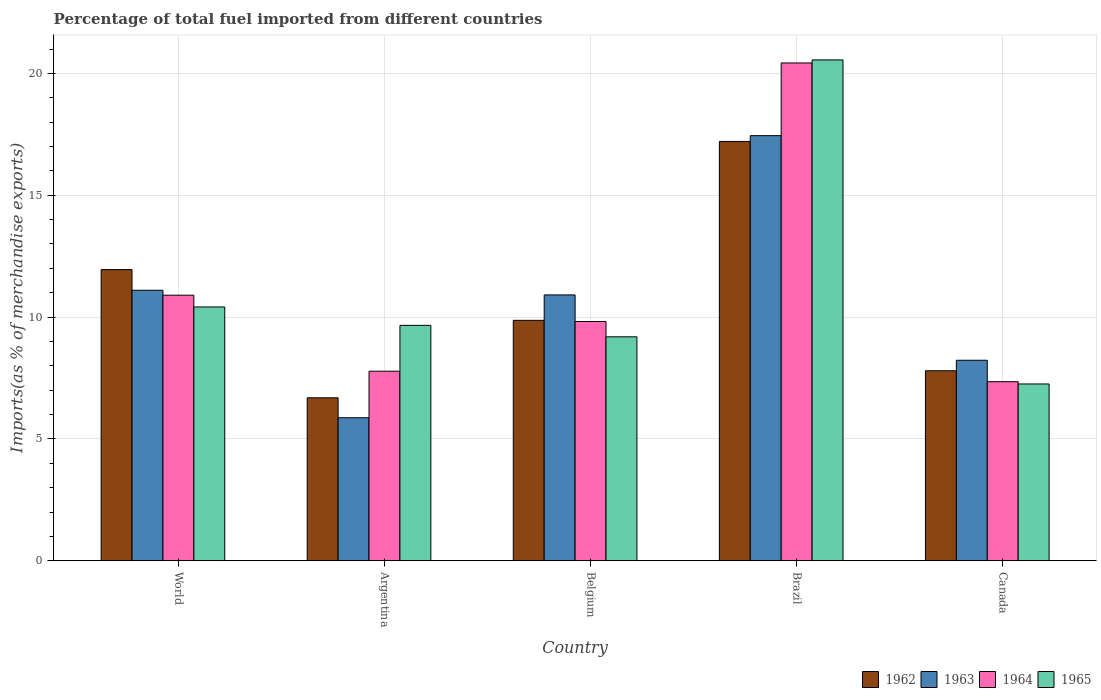How many different coloured bars are there?
Make the answer very short. 4. How many bars are there on the 5th tick from the right?
Make the answer very short. 4. In how many cases, is the number of bars for a given country not equal to the number of legend labels?
Your answer should be compact. 0. What is the percentage of imports to different countries in 1964 in World?
Give a very brief answer. 10.9. Across all countries, what is the maximum percentage of imports to different countries in 1963?
Provide a short and direct response. 17.45. Across all countries, what is the minimum percentage of imports to different countries in 1965?
Offer a terse response. 7.26. In which country was the percentage of imports to different countries in 1963 maximum?
Offer a terse response. Brazil. What is the total percentage of imports to different countries in 1964 in the graph?
Offer a terse response. 56.28. What is the difference between the percentage of imports to different countries in 1964 in Canada and that in World?
Provide a short and direct response. -3.55. What is the difference between the percentage of imports to different countries in 1965 in Argentina and the percentage of imports to different countries in 1964 in Belgium?
Your answer should be compact. -0.16. What is the average percentage of imports to different countries in 1963 per country?
Make the answer very short. 10.71. What is the difference between the percentage of imports to different countries of/in 1963 and percentage of imports to different countries of/in 1964 in Belgium?
Your answer should be very brief. 1.09. What is the ratio of the percentage of imports to different countries in 1965 in Argentina to that in Brazil?
Your answer should be very brief. 0.47. Is the percentage of imports to different countries in 1965 in Brazil less than that in Canada?
Your response must be concise. No. Is the difference between the percentage of imports to different countries in 1963 in Belgium and World greater than the difference between the percentage of imports to different countries in 1964 in Belgium and World?
Your response must be concise. Yes. What is the difference between the highest and the second highest percentage of imports to different countries in 1965?
Your answer should be very brief. -0.75. What is the difference between the highest and the lowest percentage of imports to different countries in 1963?
Your response must be concise. 11.58. In how many countries, is the percentage of imports to different countries in 1963 greater than the average percentage of imports to different countries in 1963 taken over all countries?
Ensure brevity in your answer.  3. Is the sum of the percentage of imports to different countries in 1962 in Belgium and Canada greater than the maximum percentage of imports to different countries in 1963 across all countries?
Your answer should be very brief. Yes. What does the 4th bar from the left in World represents?
Offer a very short reply. 1965. What does the 4th bar from the right in Brazil represents?
Your answer should be very brief. 1962. Is it the case that in every country, the sum of the percentage of imports to different countries in 1962 and percentage of imports to different countries in 1964 is greater than the percentage of imports to different countries in 1963?
Your answer should be very brief. Yes. How many bars are there?
Your answer should be very brief. 20. How many countries are there in the graph?
Your response must be concise. 5. Are the values on the major ticks of Y-axis written in scientific E-notation?
Make the answer very short. No. Does the graph contain any zero values?
Give a very brief answer. No. Does the graph contain grids?
Keep it short and to the point. Yes. Where does the legend appear in the graph?
Keep it short and to the point. Bottom right. How many legend labels are there?
Provide a succinct answer. 4. What is the title of the graph?
Keep it short and to the point. Percentage of total fuel imported from different countries. Does "2009" appear as one of the legend labels in the graph?
Provide a succinct answer. No. What is the label or title of the Y-axis?
Give a very brief answer. Imports(as % of merchandise exports). What is the Imports(as % of merchandise exports) of 1962 in World?
Provide a short and direct response. 11.95. What is the Imports(as % of merchandise exports) in 1963 in World?
Make the answer very short. 11.1. What is the Imports(as % of merchandise exports) of 1964 in World?
Keep it short and to the point. 10.9. What is the Imports(as % of merchandise exports) of 1965 in World?
Give a very brief answer. 10.42. What is the Imports(as % of merchandise exports) of 1962 in Argentina?
Offer a very short reply. 6.69. What is the Imports(as % of merchandise exports) in 1963 in Argentina?
Offer a terse response. 5.87. What is the Imports(as % of merchandise exports) of 1964 in Argentina?
Ensure brevity in your answer.  7.78. What is the Imports(as % of merchandise exports) in 1965 in Argentina?
Your answer should be very brief. 9.66. What is the Imports(as % of merchandise exports) in 1962 in Belgium?
Keep it short and to the point. 9.87. What is the Imports(as % of merchandise exports) of 1963 in Belgium?
Offer a terse response. 10.91. What is the Imports(as % of merchandise exports) of 1964 in Belgium?
Provide a short and direct response. 9.82. What is the Imports(as % of merchandise exports) of 1965 in Belgium?
Offer a very short reply. 9.19. What is the Imports(as % of merchandise exports) in 1962 in Brazil?
Your response must be concise. 17.21. What is the Imports(as % of merchandise exports) of 1963 in Brazil?
Give a very brief answer. 17.45. What is the Imports(as % of merchandise exports) in 1964 in Brazil?
Offer a very short reply. 20.43. What is the Imports(as % of merchandise exports) in 1965 in Brazil?
Offer a very short reply. 20.55. What is the Imports(as % of merchandise exports) in 1962 in Canada?
Offer a very short reply. 7.8. What is the Imports(as % of merchandise exports) in 1963 in Canada?
Keep it short and to the point. 8.23. What is the Imports(as % of merchandise exports) of 1964 in Canada?
Give a very brief answer. 7.35. What is the Imports(as % of merchandise exports) of 1965 in Canada?
Offer a terse response. 7.26. Across all countries, what is the maximum Imports(as % of merchandise exports) of 1962?
Provide a succinct answer. 17.21. Across all countries, what is the maximum Imports(as % of merchandise exports) in 1963?
Ensure brevity in your answer.  17.45. Across all countries, what is the maximum Imports(as % of merchandise exports) of 1964?
Offer a terse response. 20.43. Across all countries, what is the maximum Imports(as % of merchandise exports) in 1965?
Give a very brief answer. 20.55. Across all countries, what is the minimum Imports(as % of merchandise exports) of 1962?
Ensure brevity in your answer.  6.69. Across all countries, what is the minimum Imports(as % of merchandise exports) of 1963?
Keep it short and to the point. 5.87. Across all countries, what is the minimum Imports(as % of merchandise exports) of 1964?
Your answer should be compact. 7.35. Across all countries, what is the minimum Imports(as % of merchandise exports) in 1965?
Your answer should be very brief. 7.26. What is the total Imports(as % of merchandise exports) of 1962 in the graph?
Your response must be concise. 53.51. What is the total Imports(as % of merchandise exports) of 1963 in the graph?
Your response must be concise. 53.56. What is the total Imports(as % of merchandise exports) of 1964 in the graph?
Your response must be concise. 56.28. What is the total Imports(as % of merchandise exports) of 1965 in the graph?
Make the answer very short. 57.08. What is the difference between the Imports(as % of merchandise exports) of 1962 in World and that in Argentina?
Your response must be concise. 5.26. What is the difference between the Imports(as % of merchandise exports) of 1963 in World and that in Argentina?
Your answer should be compact. 5.23. What is the difference between the Imports(as % of merchandise exports) of 1964 in World and that in Argentina?
Offer a very short reply. 3.12. What is the difference between the Imports(as % of merchandise exports) of 1965 in World and that in Argentina?
Your answer should be very brief. 0.76. What is the difference between the Imports(as % of merchandise exports) in 1962 in World and that in Belgium?
Offer a very short reply. 2.08. What is the difference between the Imports(as % of merchandise exports) in 1963 in World and that in Belgium?
Offer a terse response. 0.19. What is the difference between the Imports(as % of merchandise exports) in 1964 in World and that in Belgium?
Give a very brief answer. 1.08. What is the difference between the Imports(as % of merchandise exports) of 1965 in World and that in Belgium?
Provide a short and direct response. 1.23. What is the difference between the Imports(as % of merchandise exports) of 1962 in World and that in Brazil?
Your answer should be compact. -5.26. What is the difference between the Imports(as % of merchandise exports) of 1963 in World and that in Brazil?
Your response must be concise. -6.34. What is the difference between the Imports(as % of merchandise exports) in 1964 in World and that in Brazil?
Offer a very short reply. -9.53. What is the difference between the Imports(as % of merchandise exports) of 1965 in World and that in Brazil?
Your answer should be compact. -10.14. What is the difference between the Imports(as % of merchandise exports) in 1962 in World and that in Canada?
Give a very brief answer. 4.15. What is the difference between the Imports(as % of merchandise exports) in 1963 in World and that in Canada?
Your answer should be compact. 2.87. What is the difference between the Imports(as % of merchandise exports) in 1964 in World and that in Canada?
Offer a very short reply. 3.55. What is the difference between the Imports(as % of merchandise exports) in 1965 in World and that in Canada?
Make the answer very short. 3.16. What is the difference between the Imports(as % of merchandise exports) of 1962 in Argentina and that in Belgium?
Provide a short and direct response. -3.18. What is the difference between the Imports(as % of merchandise exports) in 1963 in Argentina and that in Belgium?
Provide a succinct answer. -5.04. What is the difference between the Imports(as % of merchandise exports) in 1964 in Argentina and that in Belgium?
Provide a succinct answer. -2.04. What is the difference between the Imports(as % of merchandise exports) in 1965 in Argentina and that in Belgium?
Your answer should be compact. 0.47. What is the difference between the Imports(as % of merchandise exports) of 1962 in Argentina and that in Brazil?
Provide a short and direct response. -10.52. What is the difference between the Imports(as % of merchandise exports) in 1963 in Argentina and that in Brazil?
Your answer should be very brief. -11.58. What is the difference between the Imports(as % of merchandise exports) of 1964 in Argentina and that in Brazil?
Give a very brief answer. -12.65. What is the difference between the Imports(as % of merchandise exports) in 1965 in Argentina and that in Brazil?
Give a very brief answer. -10.89. What is the difference between the Imports(as % of merchandise exports) of 1962 in Argentina and that in Canada?
Offer a terse response. -1.11. What is the difference between the Imports(as % of merchandise exports) in 1963 in Argentina and that in Canada?
Make the answer very short. -2.36. What is the difference between the Imports(as % of merchandise exports) of 1964 in Argentina and that in Canada?
Offer a very short reply. 0.43. What is the difference between the Imports(as % of merchandise exports) in 1965 in Argentina and that in Canada?
Your answer should be compact. 2.4. What is the difference between the Imports(as % of merchandise exports) of 1962 in Belgium and that in Brazil?
Offer a very short reply. -7.34. What is the difference between the Imports(as % of merchandise exports) of 1963 in Belgium and that in Brazil?
Your answer should be compact. -6.54. What is the difference between the Imports(as % of merchandise exports) of 1964 in Belgium and that in Brazil?
Offer a terse response. -10.61. What is the difference between the Imports(as % of merchandise exports) in 1965 in Belgium and that in Brazil?
Offer a very short reply. -11.36. What is the difference between the Imports(as % of merchandise exports) of 1962 in Belgium and that in Canada?
Provide a short and direct response. 2.07. What is the difference between the Imports(as % of merchandise exports) in 1963 in Belgium and that in Canada?
Your answer should be very brief. 2.68. What is the difference between the Imports(as % of merchandise exports) of 1964 in Belgium and that in Canada?
Keep it short and to the point. 2.47. What is the difference between the Imports(as % of merchandise exports) of 1965 in Belgium and that in Canada?
Your answer should be very brief. 1.93. What is the difference between the Imports(as % of merchandise exports) of 1962 in Brazil and that in Canada?
Make the answer very short. 9.41. What is the difference between the Imports(as % of merchandise exports) in 1963 in Brazil and that in Canada?
Your answer should be compact. 9.22. What is the difference between the Imports(as % of merchandise exports) in 1964 in Brazil and that in Canada?
Provide a succinct answer. 13.08. What is the difference between the Imports(as % of merchandise exports) of 1965 in Brazil and that in Canada?
Offer a very short reply. 13.3. What is the difference between the Imports(as % of merchandise exports) of 1962 in World and the Imports(as % of merchandise exports) of 1963 in Argentina?
Offer a terse response. 6.08. What is the difference between the Imports(as % of merchandise exports) of 1962 in World and the Imports(as % of merchandise exports) of 1964 in Argentina?
Make the answer very short. 4.17. What is the difference between the Imports(as % of merchandise exports) in 1962 in World and the Imports(as % of merchandise exports) in 1965 in Argentina?
Offer a terse response. 2.29. What is the difference between the Imports(as % of merchandise exports) in 1963 in World and the Imports(as % of merchandise exports) in 1964 in Argentina?
Your answer should be very brief. 3.32. What is the difference between the Imports(as % of merchandise exports) of 1963 in World and the Imports(as % of merchandise exports) of 1965 in Argentina?
Give a very brief answer. 1.44. What is the difference between the Imports(as % of merchandise exports) in 1964 in World and the Imports(as % of merchandise exports) in 1965 in Argentina?
Ensure brevity in your answer.  1.24. What is the difference between the Imports(as % of merchandise exports) of 1962 in World and the Imports(as % of merchandise exports) of 1963 in Belgium?
Your answer should be very brief. 1.04. What is the difference between the Imports(as % of merchandise exports) of 1962 in World and the Imports(as % of merchandise exports) of 1964 in Belgium?
Keep it short and to the point. 2.13. What is the difference between the Imports(as % of merchandise exports) in 1962 in World and the Imports(as % of merchandise exports) in 1965 in Belgium?
Offer a very short reply. 2.76. What is the difference between the Imports(as % of merchandise exports) of 1963 in World and the Imports(as % of merchandise exports) of 1964 in Belgium?
Offer a terse response. 1.28. What is the difference between the Imports(as % of merchandise exports) of 1963 in World and the Imports(as % of merchandise exports) of 1965 in Belgium?
Make the answer very short. 1.91. What is the difference between the Imports(as % of merchandise exports) in 1964 in World and the Imports(as % of merchandise exports) in 1965 in Belgium?
Keep it short and to the point. 1.71. What is the difference between the Imports(as % of merchandise exports) of 1962 in World and the Imports(as % of merchandise exports) of 1963 in Brazil?
Keep it short and to the point. -5.5. What is the difference between the Imports(as % of merchandise exports) of 1962 in World and the Imports(as % of merchandise exports) of 1964 in Brazil?
Make the answer very short. -8.48. What is the difference between the Imports(as % of merchandise exports) of 1962 in World and the Imports(as % of merchandise exports) of 1965 in Brazil?
Offer a very short reply. -8.6. What is the difference between the Imports(as % of merchandise exports) in 1963 in World and the Imports(as % of merchandise exports) in 1964 in Brazil?
Give a very brief answer. -9.33. What is the difference between the Imports(as % of merchandise exports) in 1963 in World and the Imports(as % of merchandise exports) in 1965 in Brazil?
Give a very brief answer. -9.45. What is the difference between the Imports(as % of merchandise exports) of 1964 in World and the Imports(as % of merchandise exports) of 1965 in Brazil?
Your response must be concise. -9.66. What is the difference between the Imports(as % of merchandise exports) in 1962 in World and the Imports(as % of merchandise exports) in 1963 in Canada?
Give a very brief answer. 3.72. What is the difference between the Imports(as % of merchandise exports) of 1962 in World and the Imports(as % of merchandise exports) of 1964 in Canada?
Your answer should be very brief. 4.6. What is the difference between the Imports(as % of merchandise exports) in 1962 in World and the Imports(as % of merchandise exports) in 1965 in Canada?
Make the answer very short. 4.69. What is the difference between the Imports(as % of merchandise exports) in 1963 in World and the Imports(as % of merchandise exports) in 1964 in Canada?
Keep it short and to the point. 3.75. What is the difference between the Imports(as % of merchandise exports) of 1963 in World and the Imports(as % of merchandise exports) of 1965 in Canada?
Offer a very short reply. 3.85. What is the difference between the Imports(as % of merchandise exports) of 1964 in World and the Imports(as % of merchandise exports) of 1965 in Canada?
Provide a succinct answer. 3.64. What is the difference between the Imports(as % of merchandise exports) in 1962 in Argentina and the Imports(as % of merchandise exports) in 1963 in Belgium?
Provide a succinct answer. -4.22. What is the difference between the Imports(as % of merchandise exports) in 1962 in Argentina and the Imports(as % of merchandise exports) in 1964 in Belgium?
Offer a very short reply. -3.13. What is the difference between the Imports(as % of merchandise exports) of 1962 in Argentina and the Imports(as % of merchandise exports) of 1965 in Belgium?
Make the answer very short. -2.5. What is the difference between the Imports(as % of merchandise exports) in 1963 in Argentina and the Imports(as % of merchandise exports) in 1964 in Belgium?
Ensure brevity in your answer.  -3.95. What is the difference between the Imports(as % of merchandise exports) in 1963 in Argentina and the Imports(as % of merchandise exports) in 1965 in Belgium?
Ensure brevity in your answer.  -3.32. What is the difference between the Imports(as % of merchandise exports) of 1964 in Argentina and the Imports(as % of merchandise exports) of 1965 in Belgium?
Ensure brevity in your answer.  -1.41. What is the difference between the Imports(as % of merchandise exports) in 1962 in Argentina and the Imports(as % of merchandise exports) in 1963 in Brazil?
Give a very brief answer. -10.76. What is the difference between the Imports(as % of merchandise exports) of 1962 in Argentina and the Imports(as % of merchandise exports) of 1964 in Brazil?
Keep it short and to the point. -13.74. What is the difference between the Imports(as % of merchandise exports) of 1962 in Argentina and the Imports(as % of merchandise exports) of 1965 in Brazil?
Keep it short and to the point. -13.87. What is the difference between the Imports(as % of merchandise exports) of 1963 in Argentina and the Imports(as % of merchandise exports) of 1964 in Brazil?
Your answer should be very brief. -14.56. What is the difference between the Imports(as % of merchandise exports) of 1963 in Argentina and the Imports(as % of merchandise exports) of 1965 in Brazil?
Keep it short and to the point. -14.68. What is the difference between the Imports(as % of merchandise exports) of 1964 in Argentina and the Imports(as % of merchandise exports) of 1965 in Brazil?
Your answer should be compact. -12.77. What is the difference between the Imports(as % of merchandise exports) of 1962 in Argentina and the Imports(as % of merchandise exports) of 1963 in Canada?
Ensure brevity in your answer.  -1.54. What is the difference between the Imports(as % of merchandise exports) of 1962 in Argentina and the Imports(as % of merchandise exports) of 1964 in Canada?
Your answer should be compact. -0.66. What is the difference between the Imports(as % of merchandise exports) in 1962 in Argentina and the Imports(as % of merchandise exports) in 1965 in Canada?
Your response must be concise. -0.57. What is the difference between the Imports(as % of merchandise exports) in 1963 in Argentina and the Imports(as % of merchandise exports) in 1964 in Canada?
Provide a short and direct response. -1.48. What is the difference between the Imports(as % of merchandise exports) of 1963 in Argentina and the Imports(as % of merchandise exports) of 1965 in Canada?
Provide a succinct answer. -1.39. What is the difference between the Imports(as % of merchandise exports) in 1964 in Argentina and the Imports(as % of merchandise exports) in 1965 in Canada?
Provide a short and direct response. 0.52. What is the difference between the Imports(as % of merchandise exports) in 1962 in Belgium and the Imports(as % of merchandise exports) in 1963 in Brazil?
Your response must be concise. -7.58. What is the difference between the Imports(as % of merchandise exports) of 1962 in Belgium and the Imports(as % of merchandise exports) of 1964 in Brazil?
Ensure brevity in your answer.  -10.56. What is the difference between the Imports(as % of merchandise exports) in 1962 in Belgium and the Imports(as % of merchandise exports) in 1965 in Brazil?
Provide a succinct answer. -10.69. What is the difference between the Imports(as % of merchandise exports) in 1963 in Belgium and the Imports(as % of merchandise exports) in 1964 in Brazil?
Your response must be concise. -9.52. What is the difference between the Imports(as % of merchandise exports) in 1963 in Belgium and the Imports(as % of merchandise exports) in 1965 in Brazil?
Make the answer very short. -9.64. What is the difference between the Imports(as % of merchandise exports) in 1964 in Belgium and the Imports(as % of merchandise exports) in 1965 in Brazil?
Make the answer very short. -10.74. What is the difference between the Imports(as % of merchandise exports) of 1962 in Belgium and the Imports(as % of merchandise exports) of 1963 in Canada?
Make the answer very short. 1.64. What is the difference between the Imports(as % of merchandise exports) of 1962 in Belgium and the Imports(as % of merchandise exports) of 1964 in Canada?
Your response must be concise. 2.52. What is the difference between the Imports(as % of merchandise exports) in 1962 in Belgium and the Imports(as % of merchandise exports) in 1965 in Canada?
Keep it short and to the point. 2.61. What is the difference between the Imports(as % of merchandise exports) of 1963 in Belgium and the Imports(as % of merchandise exports) of 1964 in Canada?
Your answer should be compact. 3.56. What is the difference between the Imports(as % of merchandise exports) of 1963 in Belgium and the Imports(as % of merchandise exports) of 1965 in Canada?
Provide a short and direct response. 3.65. What is the difference between the Imports(as % of merchandise exports) in 1964 in Belgium and the Imports(as % of merchandise exports) in 1965 in Canada?
Make the answer very short. 2.56. What is the difference between the Imports(as % of merchandise exports) of 1962 in Brazil and the Imports(as % of merchandise exports) of 1963 in Canada?
Offer a very short reply. 8.98. What is the difference between the Imports(as % of merchandise exports) in 1962 in Brazil and the Imports(as % of merchandise exports) in 1964 in Canada?
Provide a succinct answer. 9.86. What is the difference between the Imports(as % of merchandise exports) of 1962 in Brazil and the Imports(as % of merchandise exports) of 1965 in Canada?
Ensure brevity in your answer.  9.95. What is the difference between the Imports(as % of merchandise exports) of 1963 in Brazil and the Imports(as % of merchandise exports) of 1964 in Canada?
Your response must be concise. 10.1. What is the difference between the Imports(as % of merchandise exports) in 1963 in Brazil and the Imports(as % of merchandise exports) in 1965 in Canada?
Make the answer very short. 10.19. What is the difference between the Imports(as % of merchandise exports) of 1964 in Brazil and the Imports(as % of merchandise exports) of 1965 in Canada?
Make the answer very short. 13.17. What is the average Imports(as % of merchandise exports) of 1962 per country?
Give a very brief answer. 10.7. What is the average Imports(as % of merchandise exports) of 1963 per country?
Give a very brief answer. 10.71. What is the average Imports(as % of merchandise exports) in 1964 per country?
Provide a short and direct response. 11.26. What is the average Imports(as % of merchandise exports) in 1965 per country?
Provide a short and direct response. 11.42. What is the difference between the Imports(as % of merchandise exports) of 1962 and Imports(as % of merchandise exports) of 1963 in World?
Make the answer very short. 0.85. What is the difference between the Imports(as % of merchandise exports) in 1962 and Imports(as % of merchandise exports) in 1964 in World?
Offer a terse response. 1.05. What is the difference between the Imports(as % of merchandise exports) in 1962 and Imports(as % of merchandise exports) in 1965 in World?
Provide a succinct answer. 1.53. What is the difference between the Imports(as % of merchandise exports) in 1963 and Imports(as % of merchandise exports) in 1964 in World?
Your answer should be compact. 0.2. What is the difference between the Imports(as % of merchandise exports) in 1963 and Imports(as % of merchandise exports) in 1965 in World?
Your answer should be very brief. 0.69. What is the difference between the Imports(as % of merchandise exports) of 1964 and Imports(as % of merchandise exports) of 1965 in World?
Your answer should be compact. 0.48. What is the difference between the Imports(as % of merchandise exports) in 1962 and Imports(as % of merchandise exports) in 1963 in Argentina?
Your answer should be very brief. 0.82. What is the difference between the Imports(as % of merchandise exports) of 1962 and Imports(as % of merchandise exports) of 1964 in Argentina?
Keep it short and to the point. -1.09. What is the difference between the Imports(as % of merchandise exports) in 1962 and Imports(as % of merchandise exports) in 1965 in Argentina?
Your response must be concise. -2.97. What is the difference between the Imports(as % of merchandise exports) of 1963 and Imports(as % of merchandise exports) of 1964 in Argentina?
Your answer should be compact. -1.91. What is the difference between the Imports(as % of merchandise exports) in 1963 and Imports(as % of merchandise exports) in 1965 in Argentina?
Offer a very short reply. -3.79. What is the difference between the Imports(as % of merchandise exports) in 1964 and Imports(as % of merchandise exports) in 1965 in Argentina?
Keep it short and to the point. -1.88. What is the difference between the Imports(as % of merchandise exports) of 1962 and Imports(as % of merchandise exports) of 1963 in Belgium?
Make the answer very short. -1.04. What is the difference between the Imports(as % of merchandise exports) of 1962 and Imports(as % of merchandise exports) of 1964 in Belgium?
Your answer should be very brief. 0.05. What is the difference between the Imports(as % of merchandise exports) of 1962 and Imports(as % of merchandise exports) of 1965 in Belgium?
Offer a terse response. 0.68. What is the difference between the Imports(as % of merchandise exports) of 1963 and Imports(as % of merchandise exports) of 1964 in Belgium?
Offer a very short reply. 1.09. What is the difference between the Imports(as % of merchandise exports) of 1963 and Imports(as % of merchandise exports) of 1965 in Belgium?
Give a very brief answer. 1.72. What is the difference between the Imports(as % of merchandise exports) in 1964 and Imports(as % of merchandise exports) in 1965 in Belgium?
Keep it short and to the point. 0.63. What is the difference between the Imports(as % of merchandise exports) in 1962 and Imports(as % of merchandise exports) in 1963 in Brazil?
Ensure brevity in your answer.  -0.24. What is the difference between the Imports(as % of merchandise exports) in 1962 and Imports(as % of merchandise exports) in 1964 in Brazil?
Ensure brevity in your answer.  -3.22. What is the difference between the Imports(as % of merchandise exports) of 1962 and Imports(as % of merchandise exports) of 1965 in Brazil?
Ensure brevity in your answer.  -3.35. What is the difference between the Imports(as % of merchandise exports) of 1963 and Imports(as % of merchandise exports) of 1964 in Brazil?
Offer a terse response. -2.98. What is the difference between the Imports(as % of merchandise exports) in 1963 and Imports(as % of merchandise exports) in 1965 in Brazil?
Make the answer very short. -3.11. What is the difference between the Imports(as % of merchandise exports) in 1964 and Imports(as % of merchandise exports) in 1965 in Brazil?
Offer a very short reply. -0.12. What is the difference between the Imports(as % of merchandise exports) of 1962 and Imports(as % of merchandise exports) of 1963 in Canada?
Your answer should be very brief. -0.43. What is the difference between the Imports(as % of merchandise exports) of 1962 and Imports(as % of merchandise exports) of 1964 in Canada?
Provide a short and direct response. 0.45. What is the difference between the Imports(as % of merchandise exports) in 1962 and Imports(as % of merchandise exports) in 1965 in Canada?
Give a very brief answer. 0.54. What is the difference between the Imports(as % of merchandise exports) of 1963 and Imports(as % of merchandise exports) of 1964 in Canada?
Give a very brief answer. 0.88. What is the difference between the Imports(as % of merchandise exports) in 1963 and Imports(as % of merchandise exports) in 1965 in Canada?
Provide a succinct answer. 0.97. What is the difference between the Imports(as % of merchandise exports) in 1964 and Imports(as % of merchandise exports) in 1965 in Canada?
Keep it short and to the point. 0.09. What is the ratio of the Imports(as % of merchandise exports) in 1962 in World to that in Argentina?
Your response must be concise. 1.79. What is the ratio of the Imports(as % of merchandise exports) of 1963 in World to that in Argentina?
Give a very brief answer. 1.89. What is the ratio of the Imports(as % of merchandise exports) of 1964 in World to that in Argentina?
Offer a very short reply. 1.4. What is the ratio of the Imports(as % of merchandise exports) in 1965 in World to that in Argentina?
Offer a terse response. 1.08. What is the ratio of the Imports(as % of merchandise exports) of 1962 in World to that in Belgium?
Provide a succinct answer. 1.21. What is the ratio of the Imports(as % of merchandise exports) of 1963 in World to that in Belgium?
Your answer should be compact. 1.02. What is the ratio of the Imports(as % of merchandise exports) in 1964 in World to that in Belgium?
Give a very brief answer. 1.11. What is the ratio of the Imports(as % of merchandise exports) in 1965 in World to that in Belgium?
Your answer should be very brief. 1.13. What is the ratio of the Imports(as % of merchandise exports) in 1962 in World to that in Brazil?
Provide a succinct answer. 0.69. What is the ratio of the Imports(as % of merchandise exports) in 1963 in World to that in Brazil?
Offer a very short reply. 0.64. What is the ratio of the Imports(as % of merchandise exports) of 1964 in World to that in Brazil?
Give a very brief answer. 0.53. What is the ratio of the Imports(as % of merchandise exports) in 1965 in World to that in Brazil?
Make the answer very short. 0.51. What is the ratio of the Imports(as % of merchandise exports) in 1962 in World to that in Canada?
Your answer should be compact. 1.53. What is the ratio of the Imports(as % of merchandise exports) in 1963 in World to that in Canada?
Ensure brevity in your answer.  1.35. What is the ratio of the Imports(as % of merchandise exports) in 1964 in World to that in Canada?
Your answer should be compact. 1.48. What is the ratio of the Imports(as % of merchandise exports) in 1965 in World to that in Canada?
Your answer should be very brief. 1.44. What is the ratio of the Imports(as % of merchandise exports) of 1962 in Argentina to that in Belgium?
Offer a terse response. 0.68. What is the ratio of the Imports(as % of merchandise exports) of 1963 in Argentina to that in Belgium?
Offer a very short reply. 0.54. What is the ratio of the Imports(as % of merchandise exports) in 1964 in Argentina to that in Belgium?
Give a very brief answer. 0.79. What is the ratio of the Imports(as % of merchandise exports) in 1965 in Argentina to that in Belgium?
Make the answer very short. 1.05. What is the ratio of the Imports(as % of merchandise exports) of 1962 in Argentina to that in Brazil?
Offer a terse response. 0.39. What is the ratio of the Imports(as % of merchandise exports) in 1963 in Argentina to that in Brazil?
Offer a very short reply. 0.34. What is the ratio of the Imports(as % of merchandise exports) in 1964 in Argentina to that in Brazil?
Offer a very short reply. 0.38. What is the ratio of the Imports(as % of merchandise exports) of 1965 in Argentina to that in Brazil?
Keep it short and to the point. 0.47. What is the ratio of the Imports(as % of merchandise exports) in 1962 in Argentina to that in Canada?
Keep it short and to the point. 0.86. What is the ratio of the Imports(as % of merchandise exports) of 1963 in Argentina to that in Canada?
Give a very brief answer. 0.71. What is the ratio of the Imports(as % of merchandise exports) of 1964 in Argentina to that in Canada?
Give a very brief answer. 1.06. What is the ratio of the Imports(as % of merchandise exports) in 1965 in Argentina to that in Canada?
Provide a succinct answer. 1.33. What is the ratio of the Imports(as % of merchandise exports) of 1962 in Belgium to that in Brazil?
Provide a short and direct response. 0.57. What is the ratio of the Imports(as % of merchandise exports) of 1963 in Belgium to that in Brazil?
Your answer should be very brief. 0.63. What is the ratio of the Imports(as % of merchandise exports) of 1964 in Belgium to that in Brazil?
Ensure brevity in your answer.  0.48. What is the ratio of the Imports(as % of merchandise exports) in 1965 in Belgium to that in Brazil?
Ensure brevity in your answer.  0.45. What is the ratio of the Imports(as % of merchandise exports) of 1962 in Belgium to that in Canada?
Make the answer very short. 1.27. What is the ratio of the Imports(as % of merchandise exports) in 1963 in Belgium to that in Canada?
Provide a succinct answer. 1.33. What is the ratio of the Imports(as % of merchandise exports) in 1964 in Belgium to that in Canada?
Give a very brief answer. 1.34. What is the ratio of the Imports(as % of merchandise exports) in 1965 in Belgium to that in Canada?
Provide a short and direct response. 1.27. What is the ratio of the Imports(as % of merchandise exports) in 1962 in Brazil to that in Canada?
Make the answer very short. 2.21. What is the ratio of the Imports(as % of merchandise exports) in 1963 in Brazil to that in Canada?
Your answer should be compact. 2.12. What is the ratio of the Imports(as % of merchandise exports) in 1964 in Brazil to that in Canada?
Keep it short and to the point. 2.78. What is the ratio of the Imports(as % of merchandise exports) of 1965 in Brazil to that in Canada?
Provide a short and direct response. 2.83. What is the difference between the highest and the second highest Imports(as % of merchandise exports) in 1962?
Keep it short and to the point. 5.26. What is the difference between the highest and the second highest Imports(as % of merchandise exports) of 1963?
Offer a terse response. 6.34. What is the difference between the highest and the second highest Imports(as % of merchandise exports) in 1964?
Your answer should be very brief. 9.53. What is the difference between the highest and the second highest Imports(as % of merchandise exports) of 1965?
Keep it short and to the point. 10.14. What is the difference between the highest and the lowest Imports(as % of merchandise exports) in 1962?
Your response must be concise. 10.52. What is the difference between the highest and the lowest Imports(as % of merchandise exports) of 1963?
Provide a short and direct response. 11.58. What is the difference between the highest and the lowest Imports(as % of merchandise exports) in 1964?
Give a very brief answer. 13.08. What is the difference between the highest and the lowest Imports(as % of merchandise exports) of 1965?
Your answer should be very brief. 13.3. 